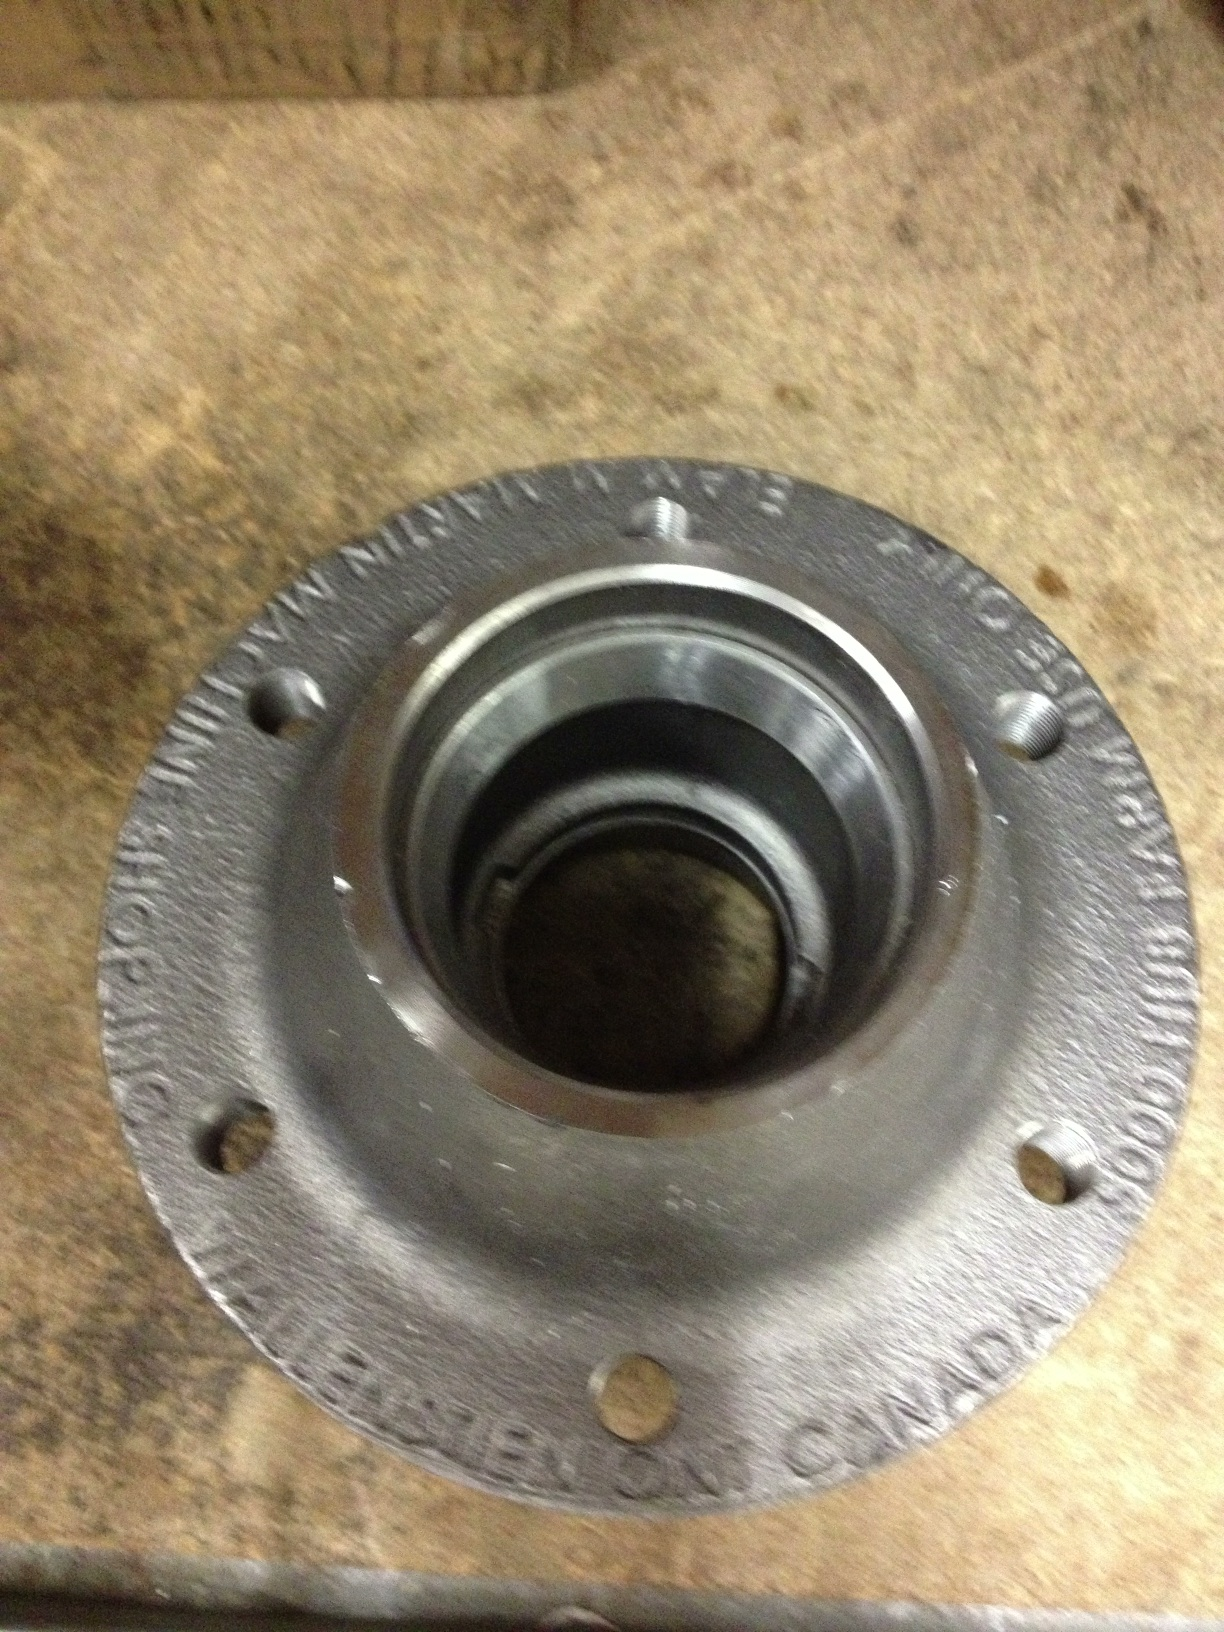How does the design of this wheel hub impact its performance? The design of this wheel hub directly affects its performance in several ways. The material used, typically high-strength steel or a similar alloy, ensures durability and the ability to withstand high loads and stresses. The precision of the machining influences the smoothness of wheel rotation and reduces friction, which enhances fuel efficiency and driving comfort. Additionally, the inclusion of bearing seals helps keep contaminants out, prolonging the life of the bearings and ensuring consistent performance. Overall, the design is critical for safety, efficiency, and longevity. Imagine if this wheel hub had a hidden compartment for storing small objects. What creative use could that serve? If this wheel hub had a hidden compartment for storing small objects, it could serve several creative and practical purposes. For instance, it could be used for storing emergency tools or spare parts like lug nuts, keeping them safe and easily accessible. In a more imaginative scenario, it could also house a GPS tracker for anti-theft purposes or even a small cache of emergency supplies for adventurous trips. This added functionality would make the wheel hub not just a mechanical component but a multi-purpose gadget aiding in various unexpected and critical situations. 